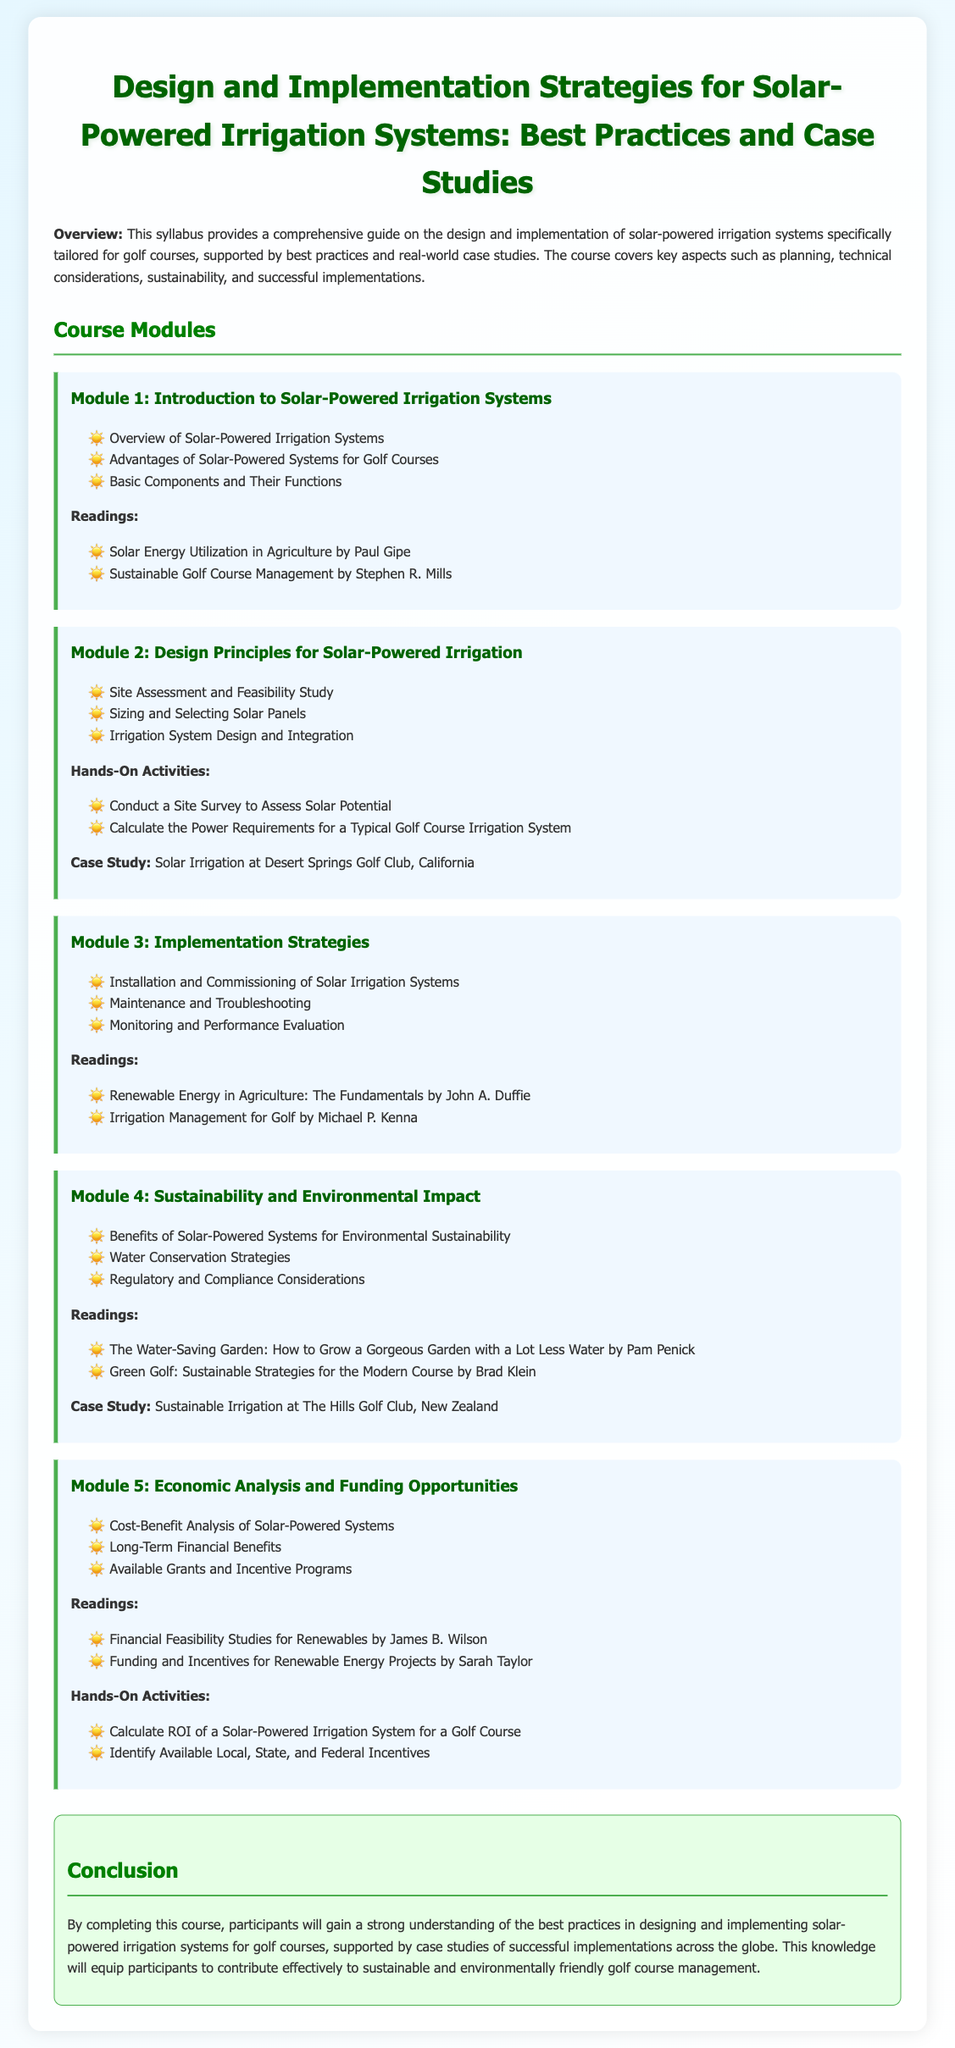What is the title of the syllabus? The title of the syllabus is stated at the top of the document, emphasizing the subject matter clearly.
Answer: Design and Implementation Strategies for Solar-Powered Irrigation Systems: Best Practices and Case Studies How many modules are included in the course? The modules are listed under "Course Modules," and counting them provides the total number.
Answer: 5 What is the case study referenced in Module 2? The case studies in each module are specified in the module details, providing real-world examples.
Answer: Solar Irrigation at Desert Springs Golf Club, California What are the hands-on activities in Module 5? The hands-on activities are detailed within the module, indicating practical exercises for participants.
Answer: Calculate ROI of a Solar-Powered Irrigation System for a Golf Course, Identify Available Local, State, and Federal Incentives Who is the author of "Solar Energy Utilization in Agriculture"? The readings section for Module 1 lists the authors of the readings, indicating who wrote the specified work.
Answer: Paul Gipe 